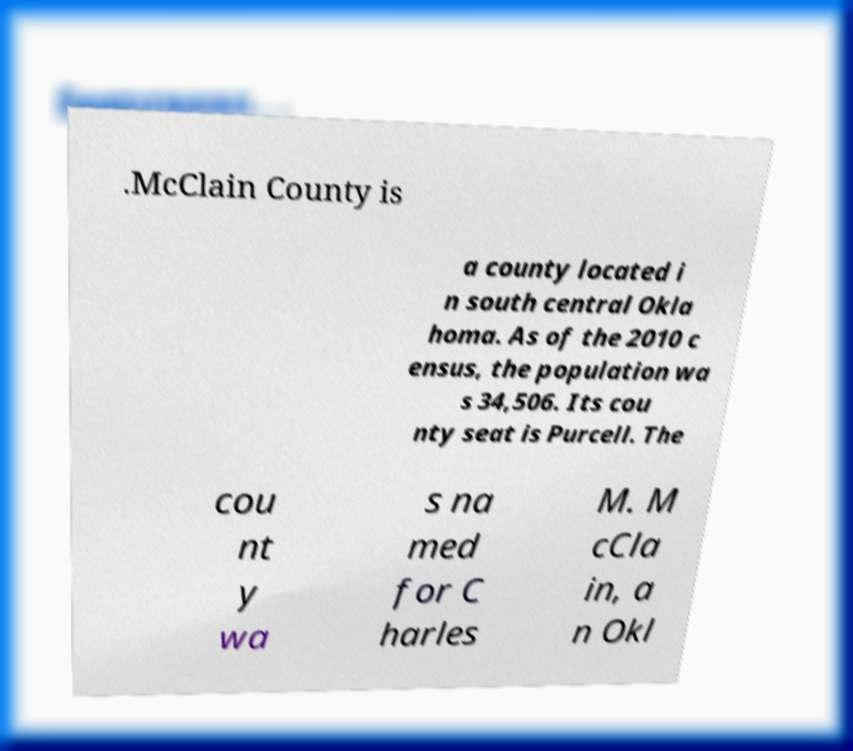Can you read and provide the text displayed in the image?This photo seems to have some interesting text. Can you extract and type it out for me? .McClain County is a county located i n south central Okla homa. As of the 2010 c ensus, the population wa s 34,506. Its cou nty seat is Purcell. The cou nt y wa s na med for C harles M. M cCla in, a n Okl 